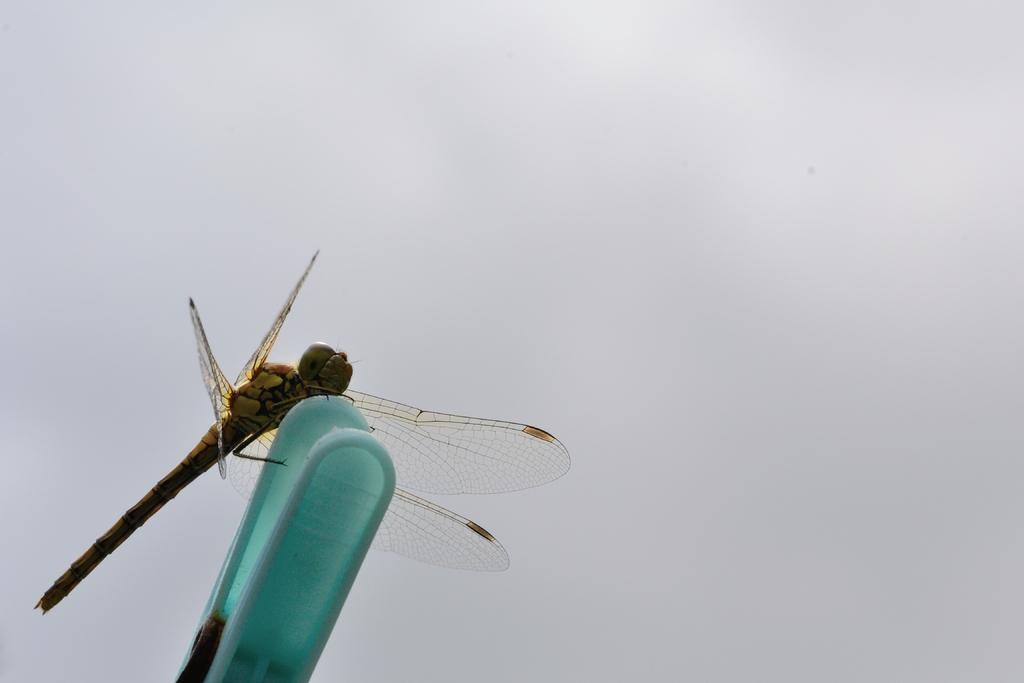In one or two sentences, can you explain what this image depicts? In this image there is a dragonfly on some clip, and in the background there is sky and the sky is cloudy. 